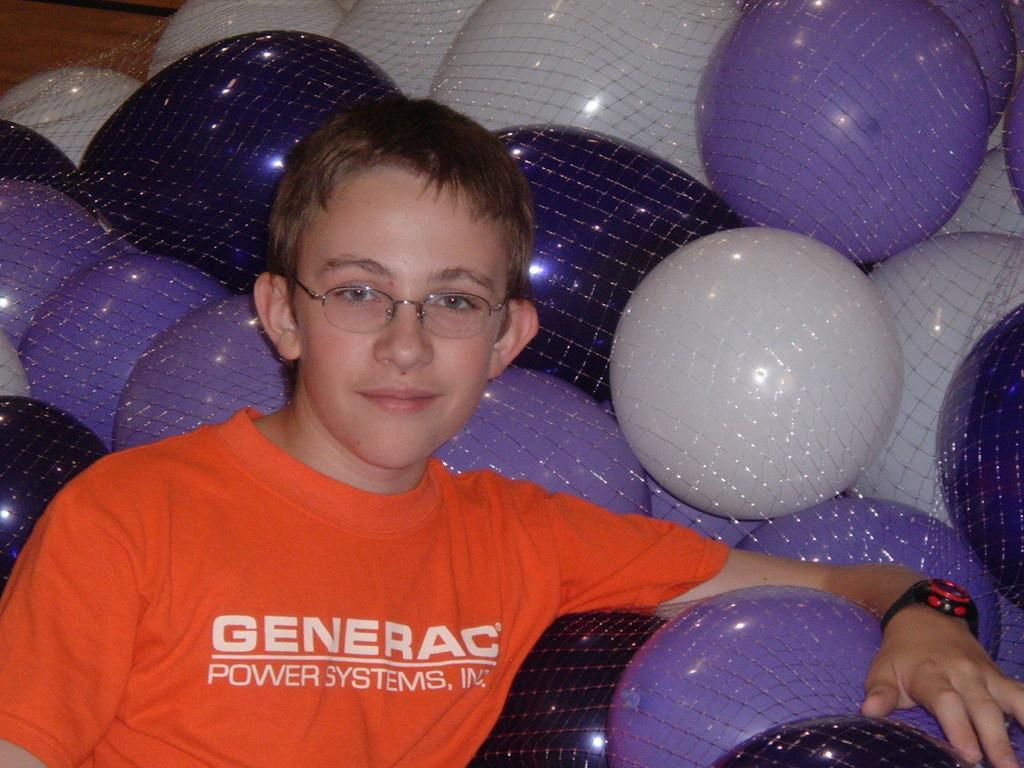In one or two sentences, can you explain what this image depicts? In this image I can see the person wearing the orange color t-shirt and the specs. To the side there are many balloons inside the net. These balloons are in white and purple color. In the background I can see the brown color surface. 